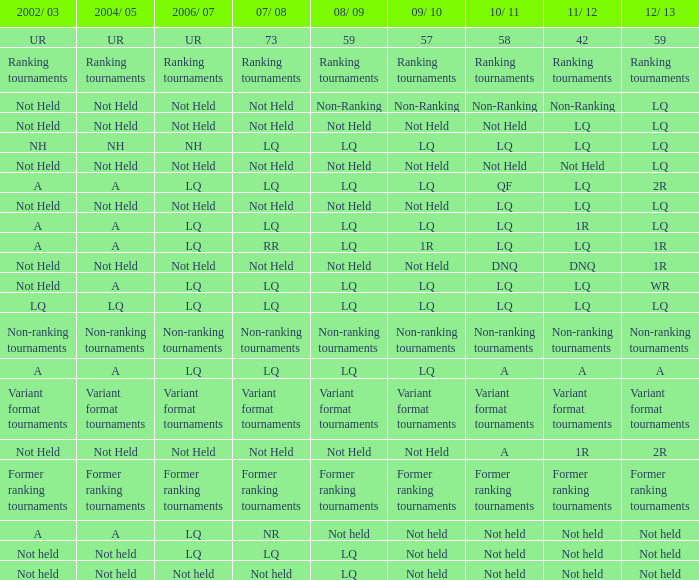Parse the table in full. {'header': ['2002/ 03', '2004/ 05', '2006/ 07', '07/ 08', '08/ 09', '09/ 10', '10/ 11', '11/ 12', '12/ 13'], 'rows': [['UR', 'UR', 'UR', '73', '59', '57', '58', '42', '59'], ['Ranking tournaments', 'Ranking tournaments', 'Ranking tournaments', 'Ranking tournaments', 'Ranking tournaments', 'Ranking tournaments', 'Ranking tournaments', 'Ranking tournaments', 'Ranking tournaments'], ['Not Held', 'Not Held', 'Not Held', 'Not Held', 'Non-Ranking', 'Non-Ranking', 'Non-Ranking', 'Non-Ranking', 'LQ'], ['Not Held', 'Not Held', 'Not Held', 'Not Held', 'Not Held', 'Not Held', 'Not Held', 'LQ', 'LQ'], ['NH', 'NH', 'NH', 'LQ', 'LQ', 'LQ', 'LQ', 'LQ', 'LQ'], ['Not Held', 'Not Held', 'Not Held', 'Not Held', 'Not Held', 'Not Held', 'Not Held', 'Not Held', 'LQ'], ['A', 'A', 'LQ', 'LQ', 'LQ', 'LQ', 'QF', 'LQ', '2R'], ['Not Held', 'Not Held', 'Not Held', 'Not Held', 'Not Held', 'Not Held', 'LQ', 'LQ', 'LQ'], ['A', 'A', 'LQ', 'LQ', 'LQ', 'LQ', 'LQ', '1R', 'LQ'], ['A', 'A', 'LQ', 'RR', 'LQ', '1R', 'LQ', 'LQ', '1R'], ['Not Held', 'Not Held', 'Not Held', 'Not Held', 'Not Held', 'Not Held', 'DNQ', 'DNQ', '1R'], ['Not Held', 'A', 'LQ', 'LQ', 'LQ', 'LQ', 'LQ', 'LQ', 'WR'], ['LQ', 'LQ', 'LQ', 'LQ', 'LQ', 'LQ', 'LQ', 'LQ', 'LQ'], ['Non-ranking tournaments', 'Non-ranking tournaments', 'Non-ranking tournaments', 'Non-ranking tournaments', 'Non-ranking tournaments', 'Non-ranking tournaments', 'Non-ranking tournaments', 'Non-ranking tournaments', 'Non-ranking tournaments'], ['A', 'A', 'LQ', 'LQ', 'LQ', 'LQ', 'A', 'A', 'A'], ['Variant format tournaments', 'Variant format tournaments', 'Variant format tournaments', 'Variant format tournaments', 'Variant format tournaments', 'Variant format tournaments', 'Variant format tournaments', 'Variant format tournaments', 'Variant format tournaments'], ['Not Held', 'Not Held', 'Not Held', 'Not Held', 'Not Held', 'Not Held', 'A', '1R', '2R'], ['Former ranking tournaments', 'Former ranking tournaments', 'Former ranking tournaments', 'Former ranking tournaments', 'Former ranking tournaments', 'Former ranking tournaments', 'Former ranking tournaments', 'Former ranking tournaments', 'Former ranking tournaments'], ['A', 'A', 'LQ', 'NR', 'Not held', 'Not held', 'Not held', 'Not held', 'Not held'], ['Not held', 'Not held', 'LQ', 'LQ', 'LQ', 'Not held', 'Not held', 'Not held', 'Not held'], ['Not held', 'Not held', 'Not held', 'Not held', 'LQ', 'Not held', 'Not held', 'Not held', 'Not held']]} Name the 2006/07 with 2011/12 of lq and 2010/11 of lq with 2002/03 of lq LQ. 